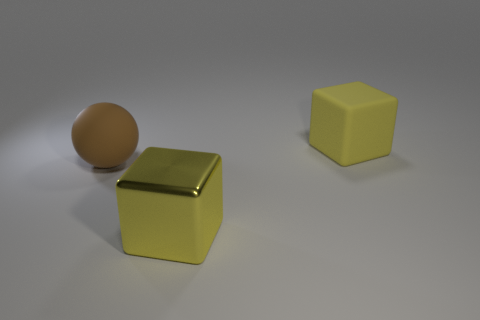The cube that is made of the same material as the big brown ball is what size?
Offer a very short reply. Large. What number of brown balls have the same size as the yellow matte block?
Provide a succinct answer. 1. What is the size of the object that is the same color as the matte cube?
Offer a very short reply. Large. What is the color of the cube left of the yellow thing to the right of the yellow shiny cube?
Make the answer very short. Yellow. Are there any other large matte cubes of the same color as the matte block?
Give a very brief answer. No. What is the color of the shiny cube that is the same size as the matte ball?
Provide a succinct answer. Yellow. Do the large yellow thing right of the large metallic thing and the brown thing have the same material?
Provide a succinct answer. Yes. There is a yellow cube that is on the right side of the thing that is in front of the brown sphere; are there any brown matte things to the right of it?
Offer a very short reply. No. Does the big thing to the left of the large yellow shiny cube have the same shape as the yellow metallic thing?
Your answer should be compact. No. The big rubber thing that is in front of the yellow thing right of the shiny object is what shape?
Your answer should be compact. Sphere. 